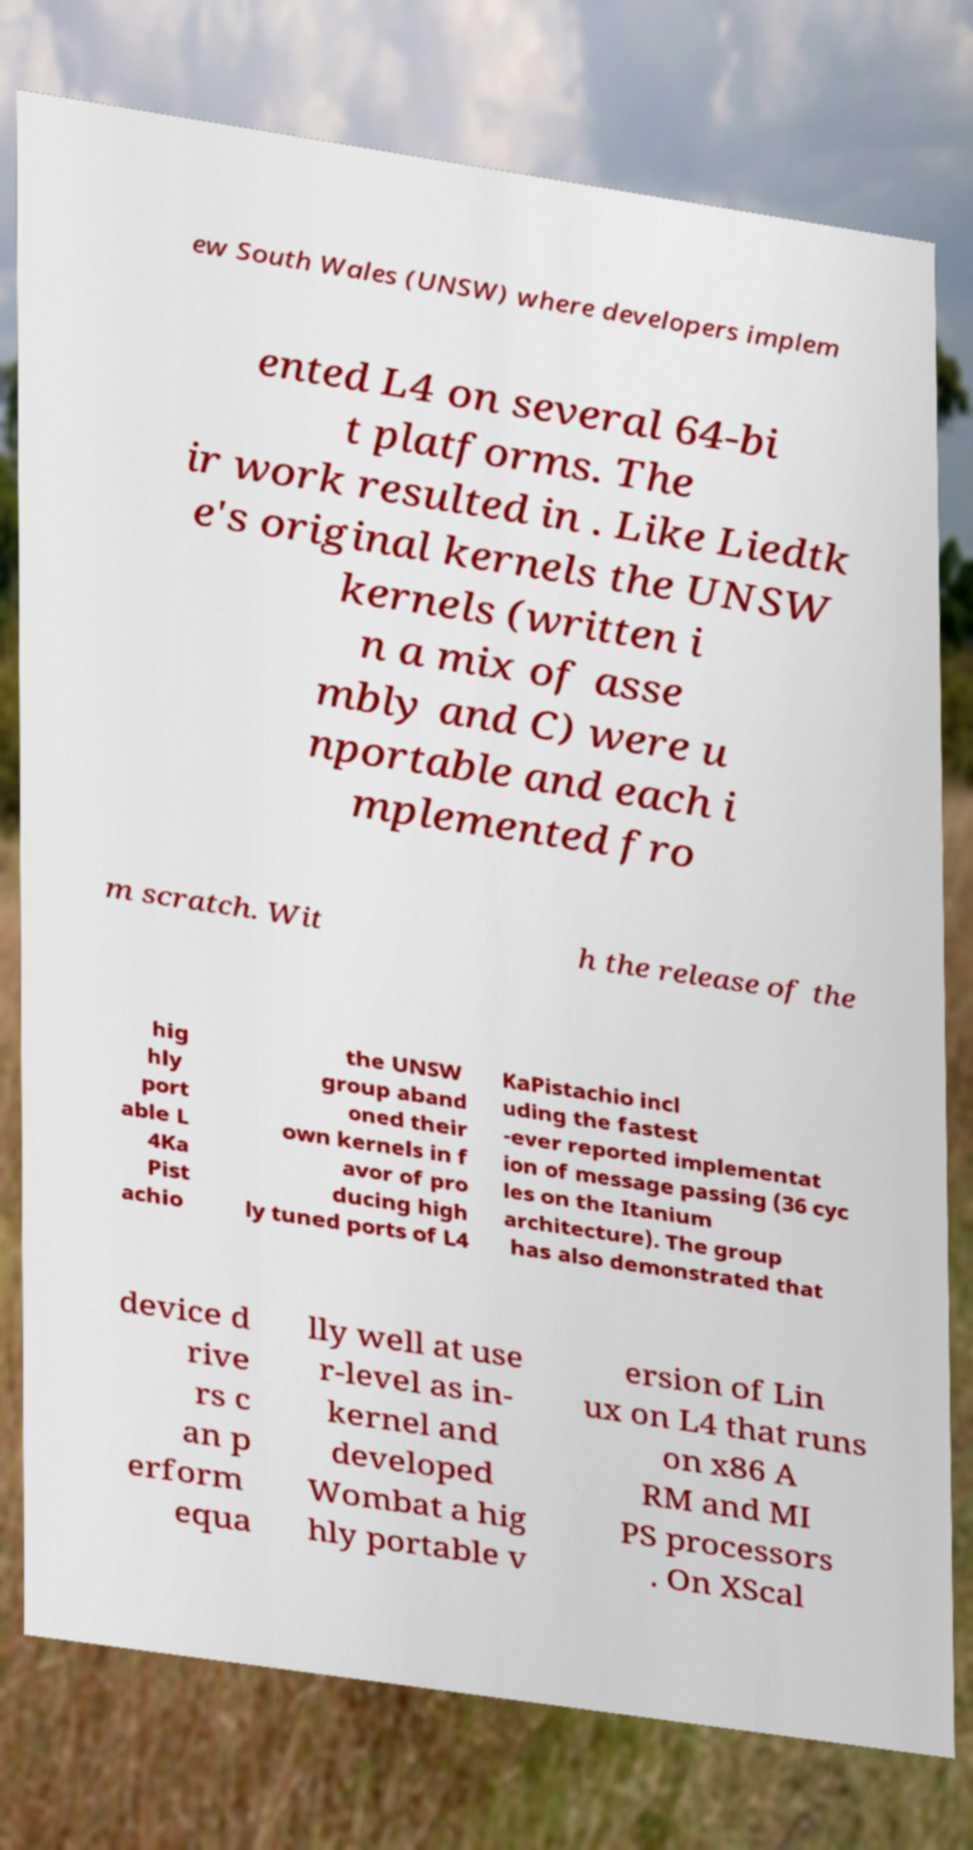What messages or text are displayed in this image? I need them in a readable, typed format. ew South Wales (UNSW) where developers implem ented L4 on several 64-bi t platforms. The ir work resulted in . Like Liedtk e's original kernels the UNSW kernels (written i n a mix of asse mbly and C) were u nportable and each i mplemented fro m scratch. Wit h the release of the hig hly port able L 4Ka Pist achio the UNSW group aband oned their own kernels in f avor of pro ducing high ly tuned ports of L4 KaPistachio incl uding the fastest -ever reported implementat ion of message passing (36 cyc les on the Itanium architecture). The group has also demonstrated that device d rive rs c an p erform equa lly well at use r-level as in- kernel and developed Wombat a hig hly portable v ersion of Lin ux on L4 that runs on x86 A RM and MI PS processors . On XScal 